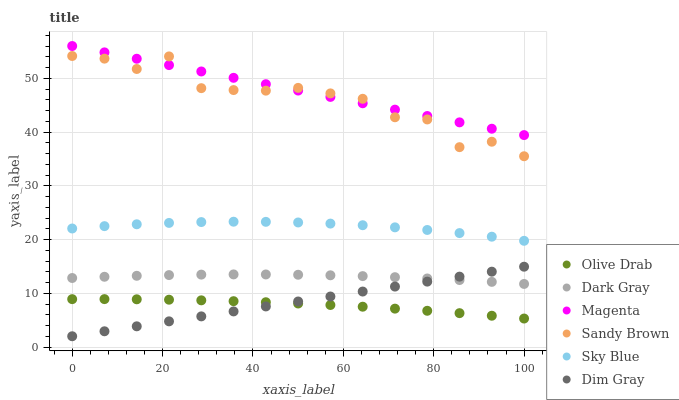Does Olive Drab have the minimum area under the curve?
Answer yes or no. Yes. Does Magenta have the maximum area under the curve?
Answer yes or no. Yes. Does Dark Gray have the minimum area under the curve?
Answer yes or no. No. Does Dark Gray have the maximum area under the curve?
Answer yes or no. No. Is Dim Gray the smoothest?
Answer yes or no. Yes. Is Sandy Brown the roughest?
Answer yes or no. Yes. Is Dark Gray the smoothest?
Answer yes or no. No. Is Dark Gray the roughest?
Answer yes or no. No. Does Dim Gray have the lowest value?
Answer yes or no. Yes. Does Dark Gray have the lowest value?
Answer yes or no. No. Does Magenta have the highest value?
Answer yes or no. Yes. Does Dark Gray have the highest value?
Answer yes or no. No. Is Dim Gray less than Sandy Brown?
Answer yes or no. Yes. Is Magenta greater than Olive Drab?
Answer yes or no. Yes. Does Sandy Brown intersect Magenta?
Answer yes or no. Yes. Is Sandy Brown less than Magenta?
Answer yes or no. No. Is Sandy Brown greater than Magenta?
Answer yes or no. No. Does Dim Gray intersect Sandy Brown?
Answer yes or no. No. 